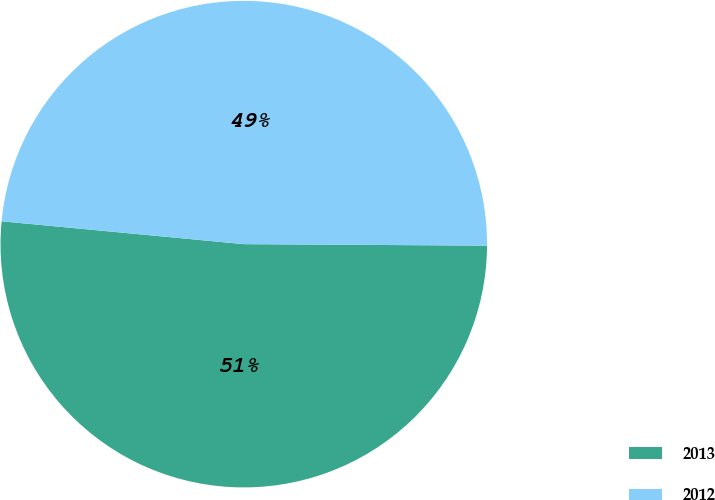Convert chart. <chart><loc_0><loc_0><loc_500><loc_500><pie_chart><fcel>2013<fcel>2012<nl><fcel>51.4%<fcel>48.6%<nl></chart> 